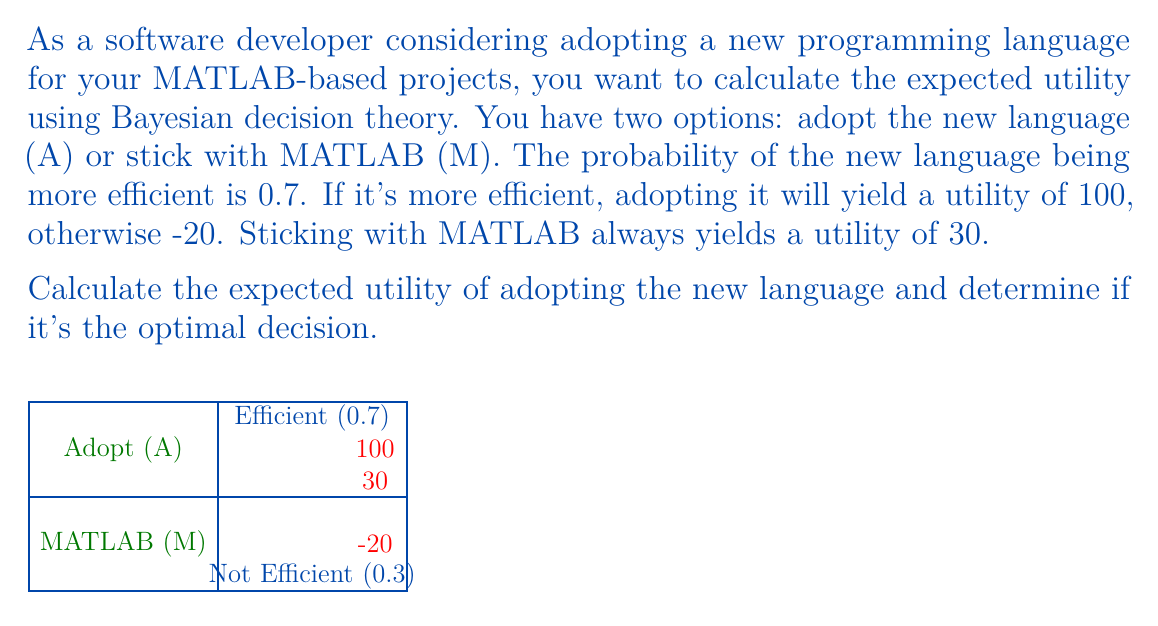Provide a solution to this math problem. Let's approach this step-by-step using Bayesian decision theory:

1) First, we need to calculate the expected utility of adopting the new language (A):

   $E(U_A) = P(\text{Efficient}) \cdot U(\text{Efficient}) + P(\text{Not Efficient}) \cdot U(\text{Not Efficient})$
   
   $E(U_A) = 0.7 \cdot 100 + 0.3 \cdot (-20)$
   
   $E(U_A) = 70 - 6 = 64$

2) The expected utility of sticking with MATLAB (M) is simply:

   $E(U_M) = 30$

3) To determine the optimal decision, we compare the expected utilities:

   $E(U_A) = 64 > E(U_M) = 30$

Therefore, adopting the new language has a higher expected utility.

4) To calculate the difference in expected utility:

   $\Delta E(U) = E(U_A) - E(U_M) = 64 - 30 = 34$

This positive value indicates that adopting the new language is the optimal decision, with an expected gain of 34 utility units compared to sticking with MATLAB.
Answer: $E(U_A) = 64$; Adopt new language 